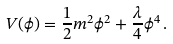<formula> <loc_0><loc_0><loc_500><loc_500>V ( \phi ) = \frac { 1 } { 2 } m ^ { 2 } \phi ^ { 2 } + \frac { \lambda } { 4 } \phi ^ { 4 } \, .</formula> 